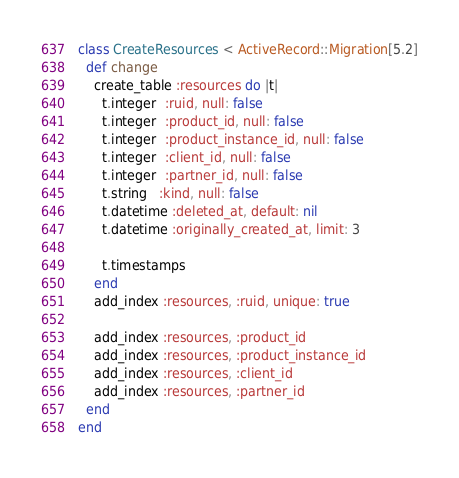<code> <loc_0><loc_0><loc_500><loc_500><_Ruby_>class CreateResources < ActiveRecord::Migration[5.2]
  def change
    create_table :resources do |t|
      t.integer  :ruid, null: false
      t.integer  :product_id, null: false
      t.integer  :product_instance_id, null: false
      t.integer  :client_id, null: false
      t.integer  :partner_id, null: false
      t.string   :kind, null: false
      t.datetime :deleted_at, default: nil
      t.datetime :originally_created_at, limit: 3

      t.timestamps
    end
    add_index :resources, :ruid, unique: true

    add_index :resources, :product_id
    add_index :resources, :product_instance_id
    add_index :resources, :client_id
    add_index :resources, :partner_id
  end
end
</code> 